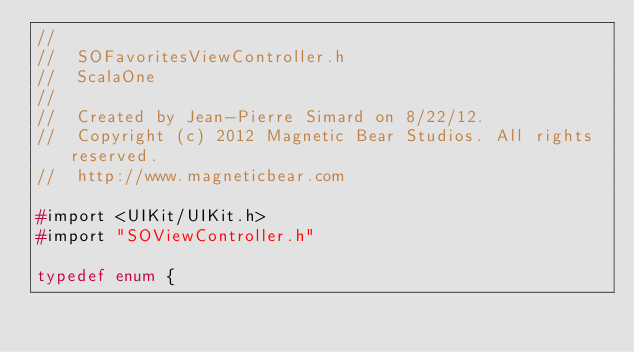<code> <loc_0><loc_0><loc_500><loc_500><_C_>//
//  SOFavoritesViewController.h
//  ScalaOne
//
//  Created by Jean-Pierre Simard on 8/22/12.
//  Copyright (c) 2012 Magnetic Bear Studios. All rights reserved.
//  http://www.magneticbear.com

#import <UIKit/UIKit.h>
#import "SOViewController.h"

typedef enum {</code> 